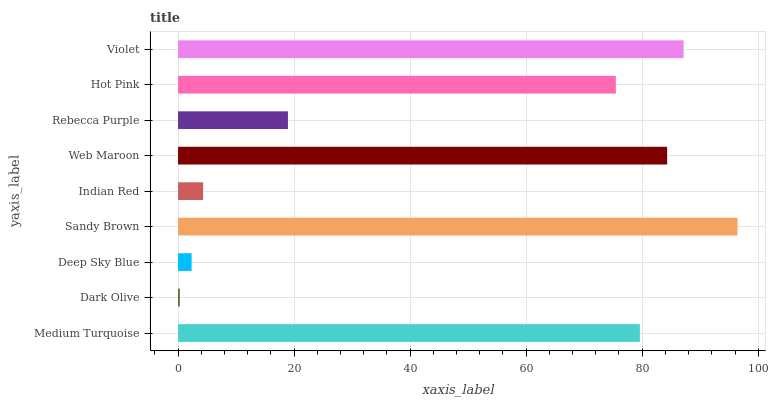Is Dark Olive the minimum?
Answer yes or no. Yes. Is Sandy Brown the maximum?
Answer yes or no. Yes. Is Deep Sky Blue the minimum?
Answer yes or no. No. Is Deep Sky Blue the maximum?
Answer yes or no. No. Is Deep Sky Blue greater than Dark Olive?
Answer yes or no. Yes. Is Dark Olive less than Deep Sky Blue?
Answer yes or no. Yes. Is Dark Olive greater than Deep Sky Blue?
Answer yes or no. No. Is Deep Sky Blue less than Dark Olive?
Answer yes or no. No. Is Hot Pink the high median?
Answer yes or no. Yes. Is Hot Pink the low median?
Answer yes or no. Yes. Is Rebecca Purple the high median?
Answer yes or no. No. Is Rebecca Purple the low median?
Answer yes or no. No. 